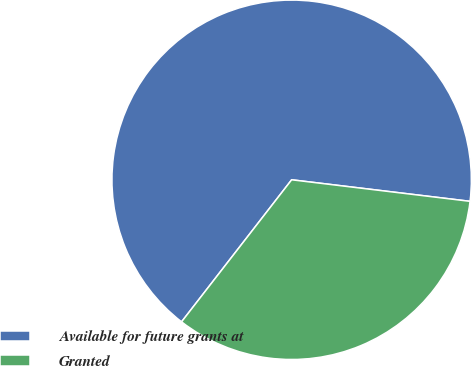<chart> <loc_0><loc_0><loc_500><loc_500><pie_chart><fcel>Available for future grants at<fcel>Granted<nl><fcel>66.42%<fcel>33.58%<nl></chart> 